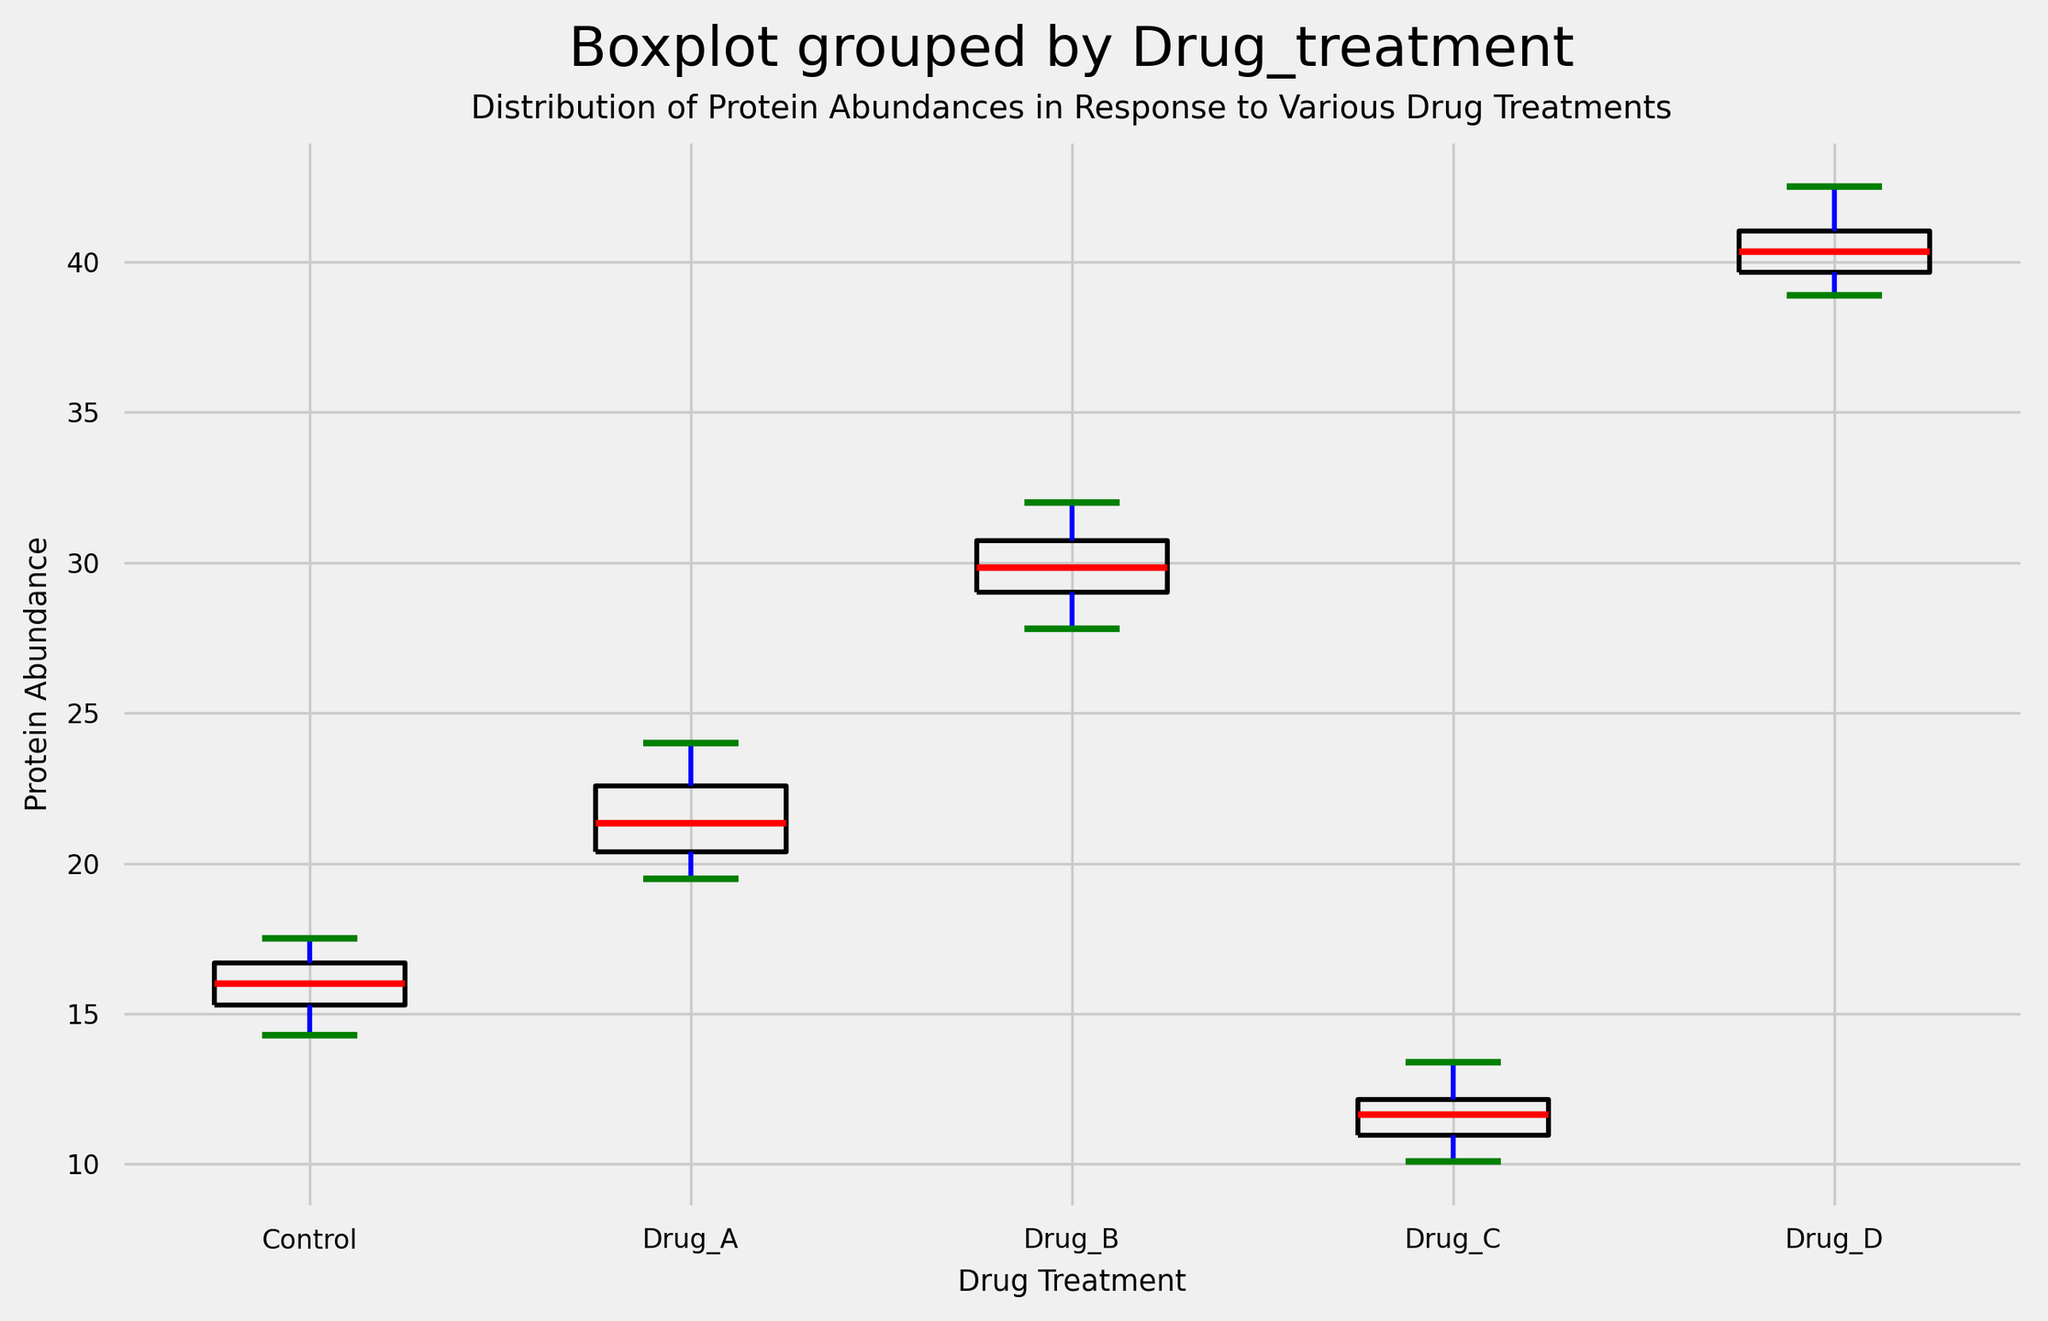What is the median protein abundance for Drug A? To determine the median protein abundance for Drug A, observe the middle value when the data points for Drug A are ordered sequentially. The data points for Drug A are: 19.5, 19.8, 20.2, 20.9, 21.1, 21.6, 22.2, 22.7, 23.5, and 24.0. The median is the middle value when there are 10 numbers, which is the average of the 5th and 6th values: (21.1 + 21.6) / 2 = 21.35.
Answer: 21.35 Which drug treatment has the highest median protein abundance? Compare the median values of the box plots for each drug treatment. Drug D shows the highest median protein abundance visually, as the red line (indicating the median) for Drug D is clearly higher than the others.
Answer: Drug D Are there any outliers present in the Protein Abundance data for any of the drug treatments? Outliers in box plots are typically shown as markers outside the whiskers. Upon examining the plot, Drug A and Drug C show some markers outside their whiskers, indicating the presence of outliers.
Answer: Yes Compare the interquartile ranges (IQRs) of Control and Drug B. Which is larger? The IQR is the range between the first (bottom of the box) and third quartile (top of the box). By comparing the length of the boxes for Control and Drug B, it is clear that Drug B has a larger IQR as the box is taller.
Answer: Drug B What is the approximate range of protein abundance values for Drug C? The range of protein abundance for Drug C can be determined by looking at the whiskers. For Drug C, the lowest value is around 10.1, and the highest value is around 13.4, giving a range of approximately 13.4 - 10.1 = 3.3.
Answer: 3.3 Which drug treatment shows the most variability in protein abundance values? Variability can be observed by comparing the length of the whiskers and the height of the boxplots. Drug D has the longest whiskers and the tallest box, indicating the most variability.
Answer: Drug D Between Control and Drug A, which one has a lower minimum protein abundance? The minimum protein abundance can be identified by looking at the bottom whisker of each box plot. For Control, the minimum value is around 14.3, while for Drug A, it is around 19.5. Therefore, Control has a lower minimum protein abundance.
Answer: Control Is the median protein abundance for Drug C higher than that for Control? By visually comparing the red lines (indicating medians) on the box plots for Drug C and Control, it is clear that the median value of Drug C is lower than that of Control.
Answer: No 